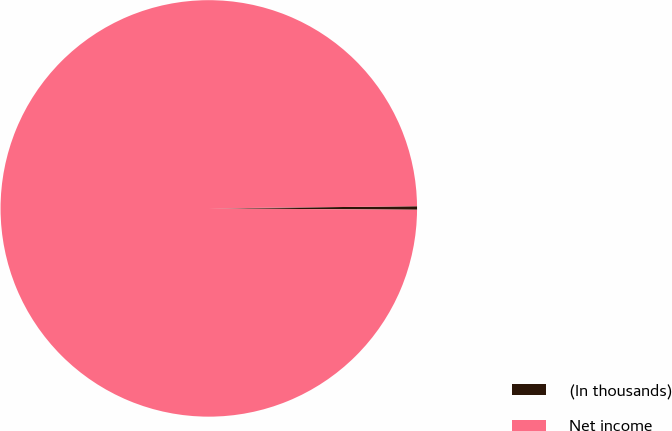<chart> <loc_0><loc_0><loc_500><loc_500><pie_chart><fcel>(In thousands)<fcel>Net income<nl><fcel>0.27%<fcel>99.73%<nl></chart> 